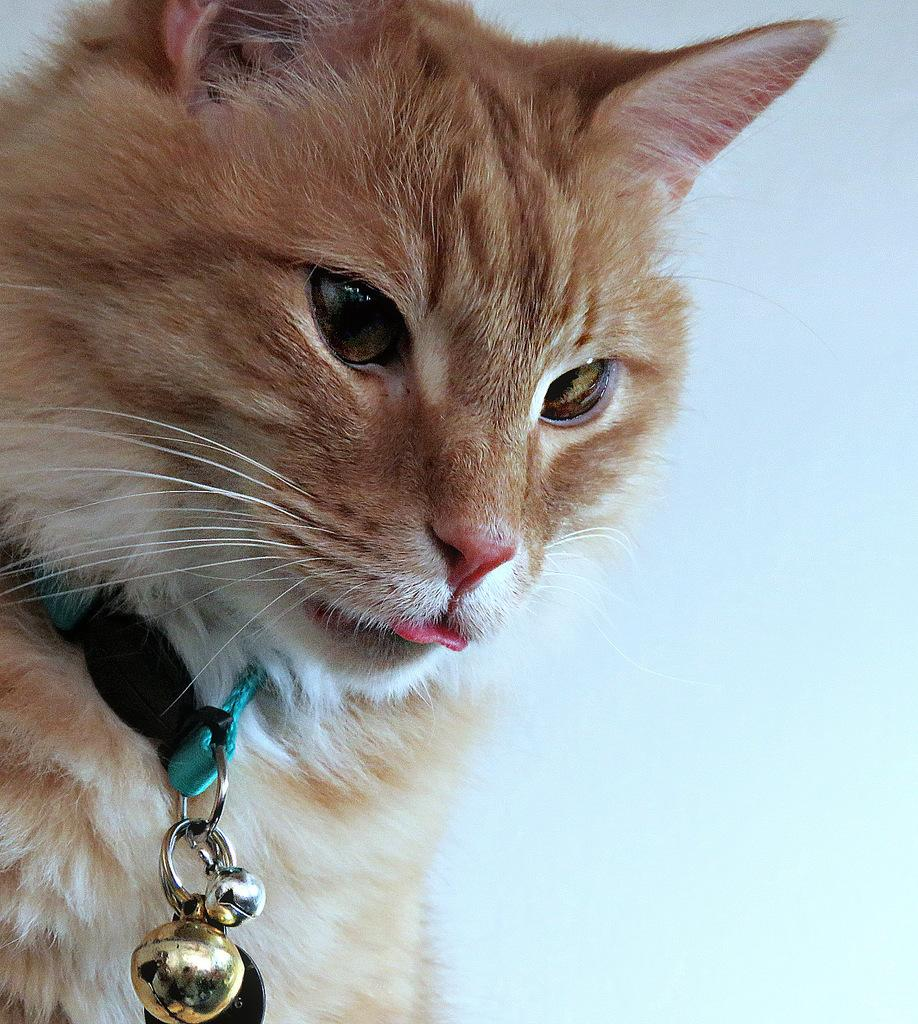What type of animal is in the image? There is a cat in the image. Can you describe the background of the image? The background of the image is blurred. Is there a volcano erupting in the background of the image? No, there is no volcano present in the image. 